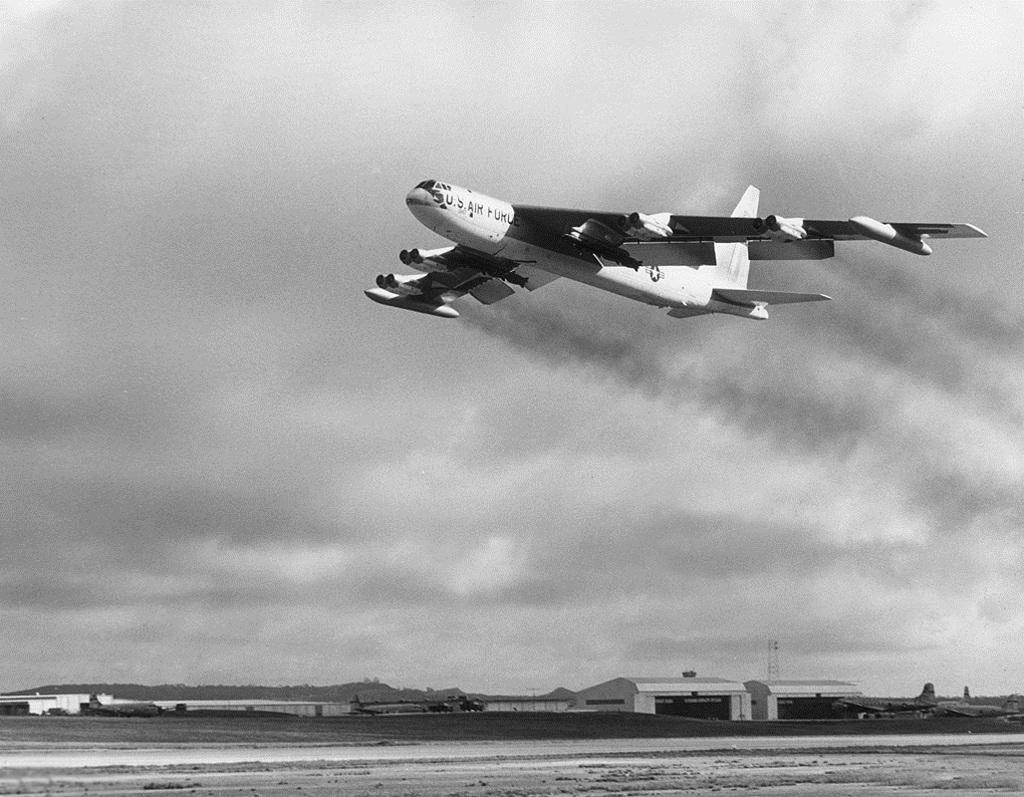<image>
Summarize the visual content of the image. A large U.S. Air Force cargo jet is flying over an airfield. 